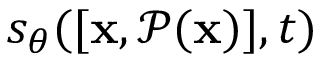<formula> <loc_0><loc_0><loc_500><loc_500>s _ { \theta } ( [ x , \mathcal { P ( x ) } ] , t )</formula> 